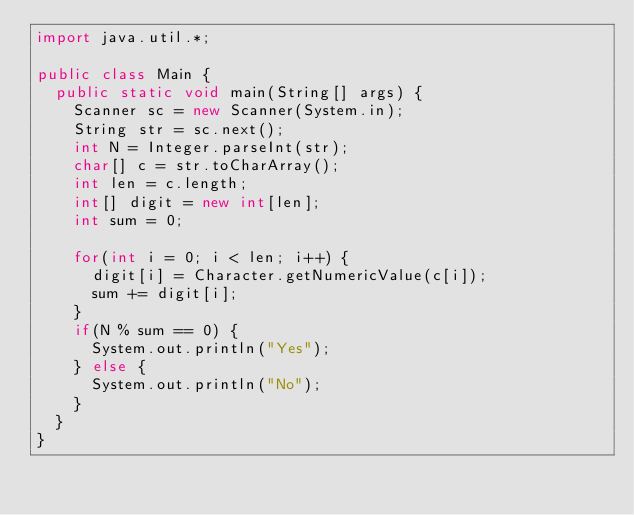Convert code to text. <code><loc_0><loc_0><loc_500><loc_500><_Java_>import java.util.*;

public class Main {
  public static void main(String[] args) {
    Scanner sc = new Scanner(System.in);
    String str = sc.next();
    int N = Integer.parseInt(str);
    char[] c = str.toCharArray();
    int len = c.length;
    int[] digit = new int[len];
    int sum = 0;

    for(int i = 0; i < len; i++) {
      digit[i] = Character.getNumericValue(c[i]);
      sum += digit[i];
    }
    if(N % sum == 0) {
      System.out.println("Yes");
    } else {
      System.out.println("No");
    }
  }
}</code> 